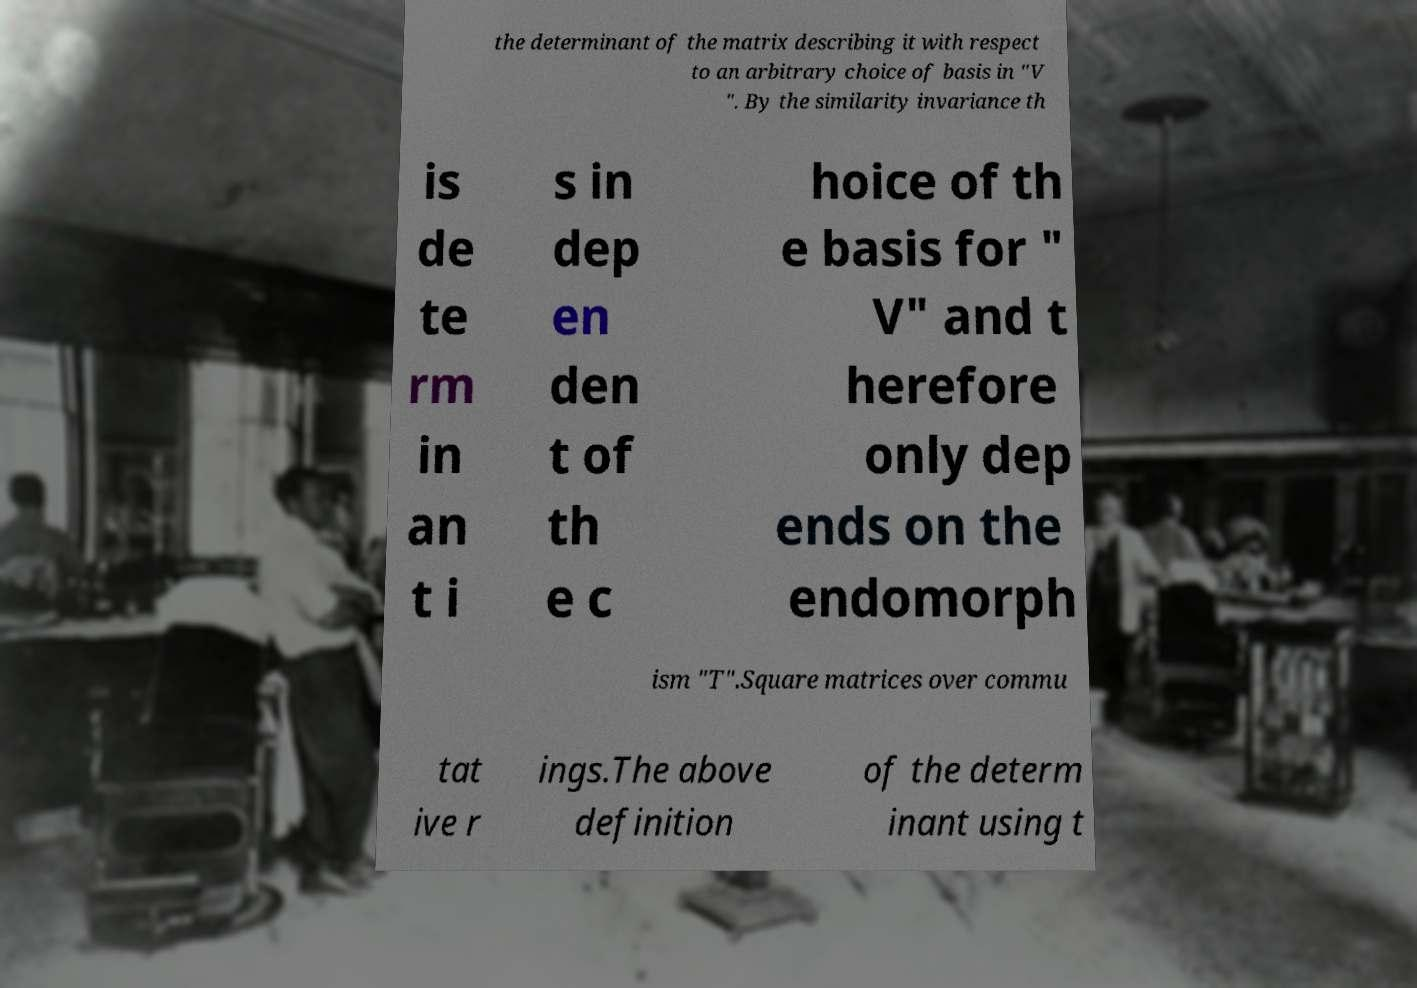Can you accurately transcribe the text from the provided image for me? the determinant of the matrix describing it with respect to an arbitrary choice of basis in "V ". By the similarity invariance th is de te rm in an t i s in dep en den t of th e c hoice of th e basis for " V" and t herefore only dep ends on the endomorph ism "T".Square matrices over commu tat ive r ings.The above definition of the determ inant using t 